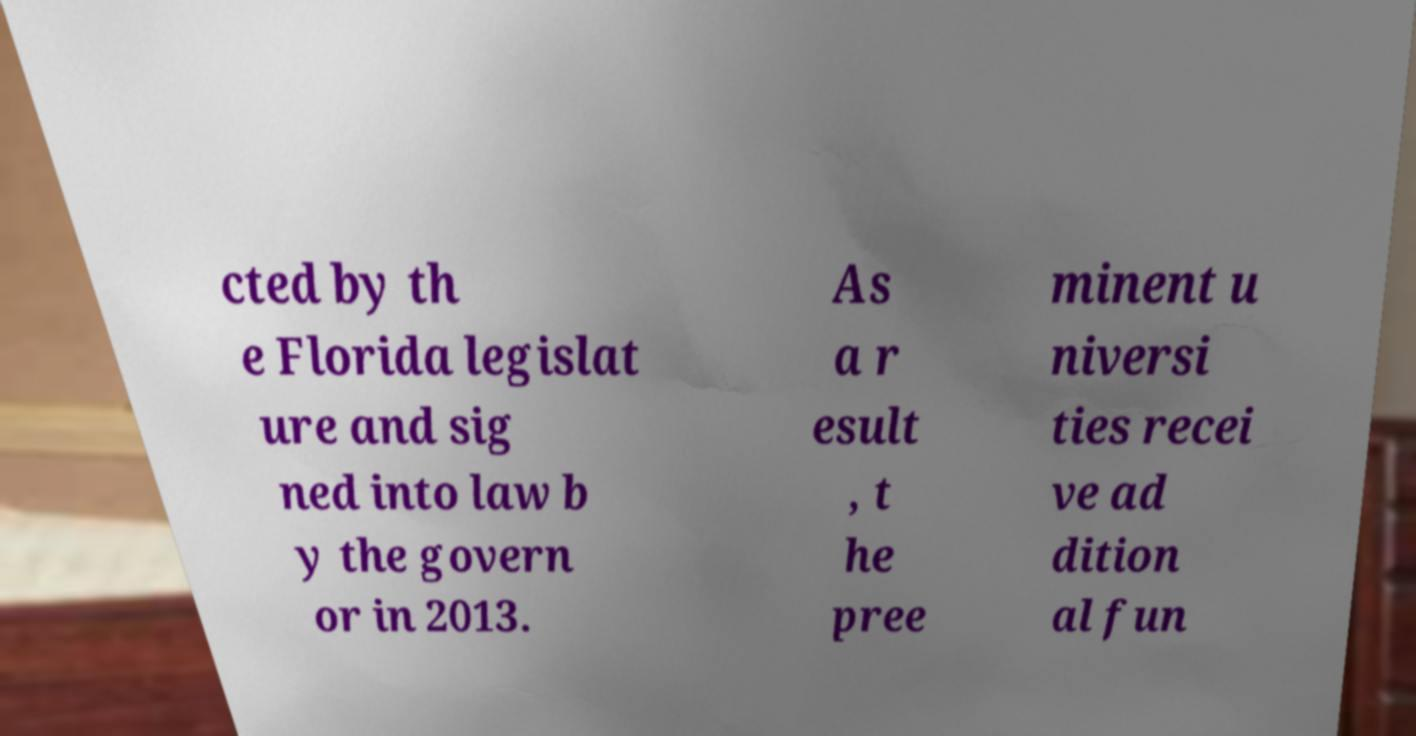What messages or text are displayed in this image? I need them in a readable, typed format. cted by th e Florida legislat ure and sig ned into law b y the govern or in 2013. As a r esult , t he pree minent u niversi ties recei ve ad dition al fun 